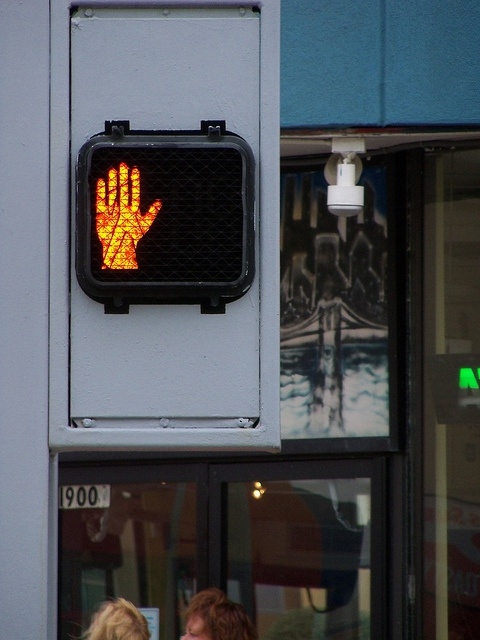Describe the objects in this image and their specific colors. I can see traffic light in gray, black, yellow, and red tones, people in gray, black, maroon, and brown tones, and people in gray, maroon, and tan tones in this image. 